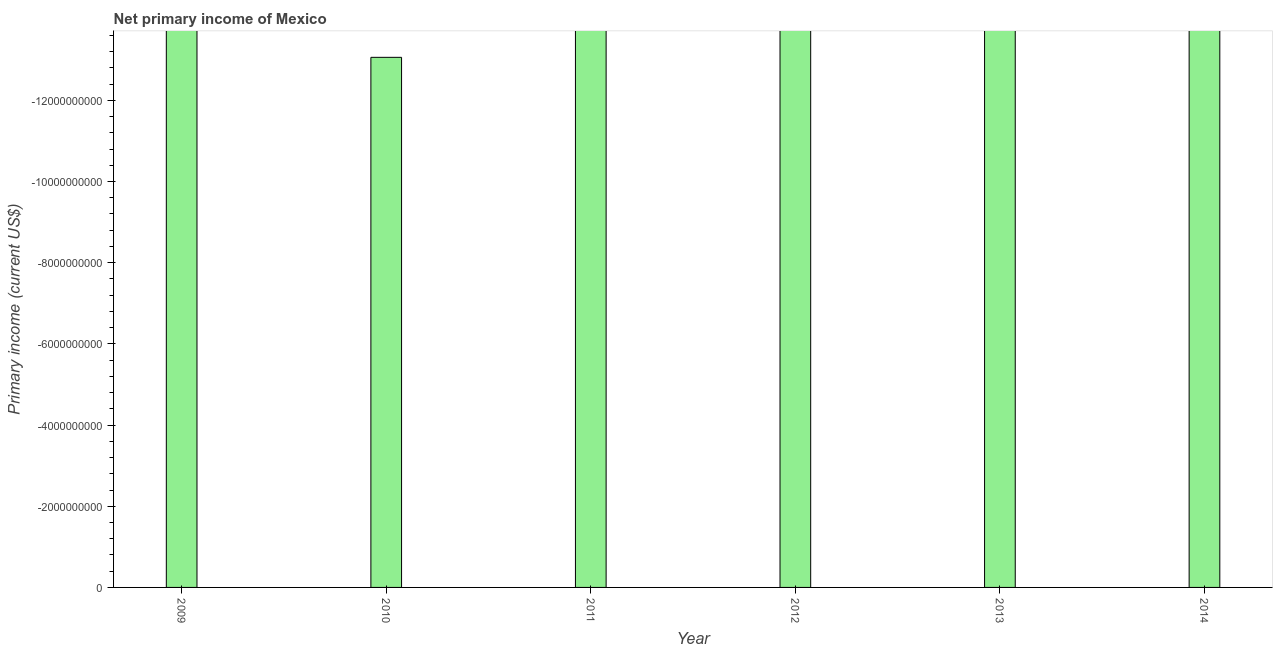Does the graph contain any zero values?
Ensure brevity in your answer.  Yes. What is the title of the graph?
Keep it short and to the point. Net primary income of Mexico. What is the label or title of the Y-axis?
Your answer should be compact. Primary income (current US$). What is the amount of primary income in 2009?
Offer a very short reply. 0. Across all years, what is the minimum amount of primary income?
Your answer should be compact. 0. In how many years, is the amount of primary income greater than -1600000000 US$?
Make the answer very short. 0. How many bars are there?
Keep it short and to the point. 0. Are all the bars in the graph horizontal?
Provide a succinct answer. No. How many years are there in the graph?
Give a very brief answer. 6. What is the difference between two consecutive major ticks on the Y-axis?
Your answer should be compact. 2.00e+09. Are the values on the major ticks of Y-axis written in scientific E-notation?
Make the answer very short. No. What is the Primary income (current US$) of 2010?
Give a very brief answer. 0. What is the Primary income (current US$) of 2011?
Your response must be concise. 0. What is the Primary income (current US$) in 2013?
Offer a terse response. 0. 